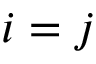<formula> <loc_0><loc_0><loc_500><loc_500>i = j</formula> 